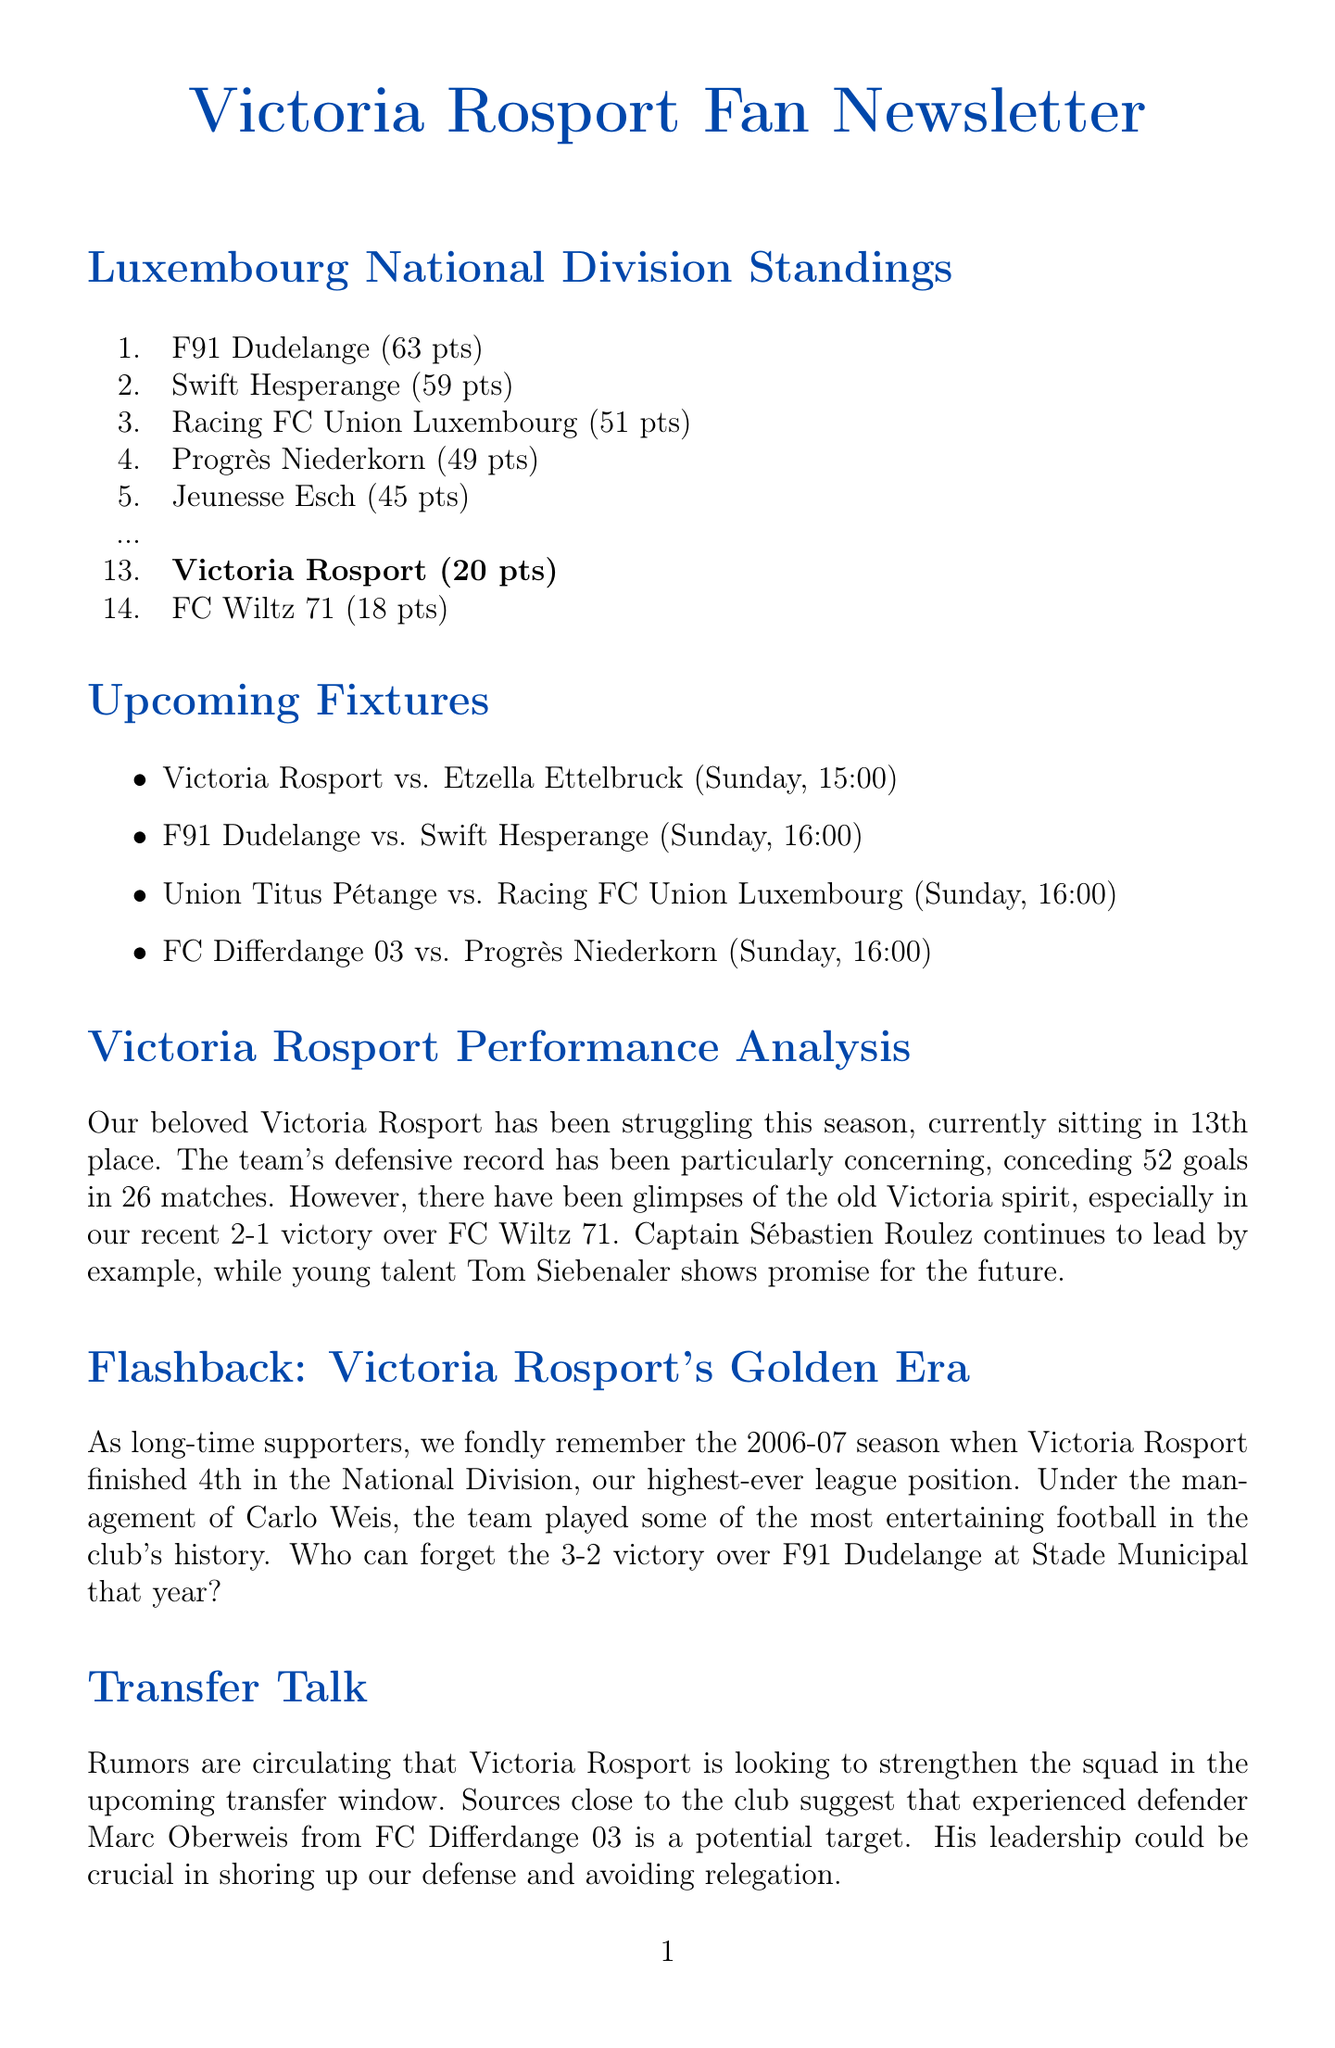What position is Victoria Rosport currently in? Victoria Rosport is currently in 13th place in the standings as stated in the document.
Answer: 13th How many goals has Victoria Rosport conceded this season? The document mentions that Victoria Rosport has conceded 52 goals in 26 matches.
Answer: 52 goals Who is the captain of Victoria Rosport? The document states that Sébastien Roulez is the captain and continues to lead by example.
Answer: Sébastien Roulez When will Victoria Rosport play against Etzella Ettelbruck? The document reports that this match is scheduled for Sunday at 15:00.
Answer: Sunday, 15:00 Which team finished 4th in the 2006-07 season? The document references that Victoria Rosport finished 4th during that season, marking their highest-ever league position.
Answer: Victoria Rosport What is the significance of Marc Oberweis in the Transfer Talk section? The document highlights that Marc Oberweis is a potential target to strengthen the squad as an experienced defender.
Answer: Experienced defender How did fans show support during the away match at Jeunesse Esch? The document notes that fans created an electric atmosphere with traditional chants and waving flags.
Answer: Chants and flags What is the upcoming fixture after Victoria Rosport's match on Sunday? The document lists the match between F91 Dudelange and Swift Hesperange as the next fixture after Rosport's.
Answer: F91 Dudelange vs. Swift Hesperange What kind of performance has Victoria Rosport shown recently? The document mentions that the team has had glimpses of the old spirit, highlighted by a recent victory.
Answer: Glimpses of the old spirit 